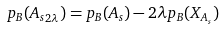<formula> <loc_0><loc_0><loc_500><loc_500>p _ { B } ( { A _ { s } } _ { 2 \lambda } ) = p _ { B } ( A _ { s } ) - 2 \lambda p _ { B } ( X _ { A _ { s } } )</formula> 